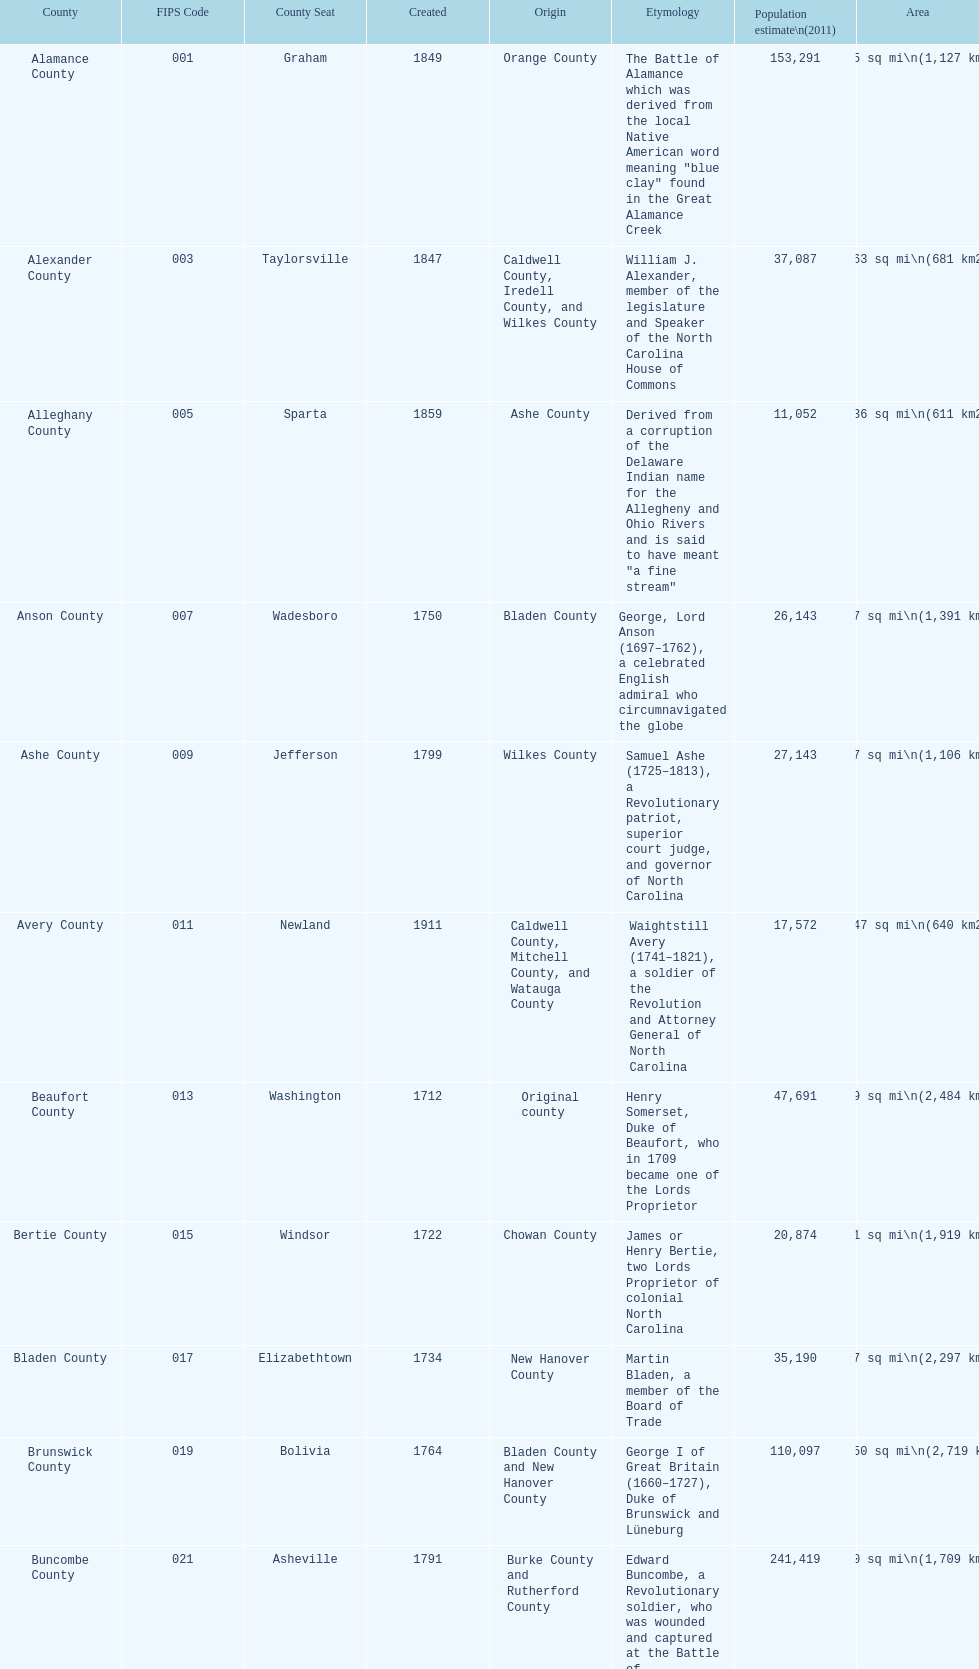What is the count of counties named in honor of us presidents? 3. 